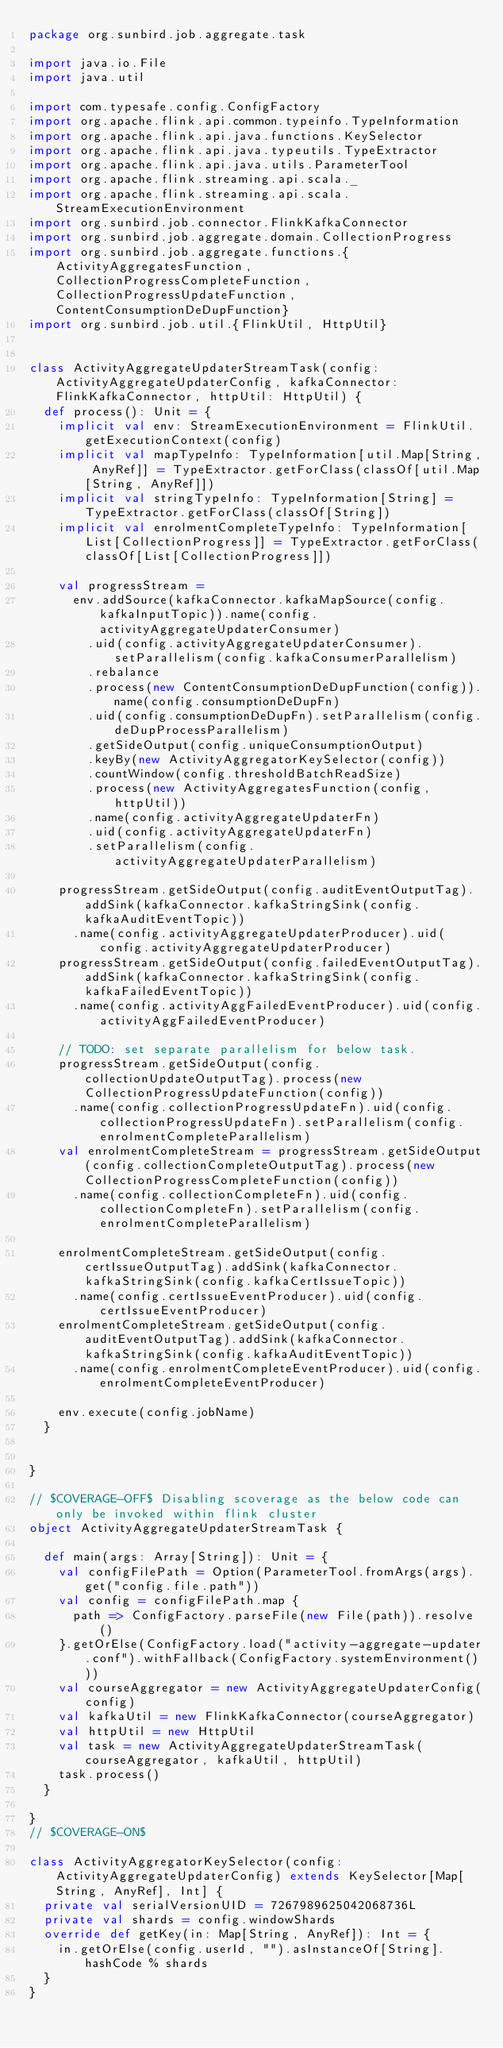Convert code to text. <code><loc_0><loc_0><loc_500><loc_500><_Scala_>package org.sunbird.job.aggregate.task

import java.io.File
import java.util

import com.typesafe.config.ConfigFactory
import org.apache.flink.api.common.typeinfo.TypeInformation
import org.apache.flink.api.java.functions.KeySelector
import org.apache.flink.api.java.typeutils.TypeExtractor
import org.apache.flink.api.java.utils.ParameterTool
import org.apache.flink.streaming.api.scala._
import org.apache.flink.streaming.api.scala.StreamExecutionEnvironment
import org.sunbird.job.connector.FlinkKafkaConnector
import org.sunbird.job.aggregate.domain.CollectionProgress
import org.sunbird.job.aggregate.functions.{ActivityAggregatesFunction, CollectionProgressCompleteFunction, CollectionProgressUpdateFunction, ContentConsumptionDeDupFunction}
import org.sunbird.job.util.{FlinkUtil, HttpUtil}


class ActivityAggregateUpdaterStreamTask(config: ActivityAggregateUpdaterConfig, kafkaConnector: FlinkKafkaConnector, httpUtil: HttpUtil) {
  def process(): Unit = {
    implicit val env: StreamExecutionEnvironment = FlinkUtil.getExecutionContext(config)
    implicit val mapTypeInfo: TypeInformation[util.Map[String, AnyRef]] = TypeExtractor.getForClass(classOf[util.Map[String, AnyRef]])
    implicit val stringTypeInfo: TypeInformation[String] = TypeExtractor.getForClass(classOf[String])
    implicit val enrolmentCompleteTypeInfo: TypeInformation[List[CollectionProgress]] = TypeExtractor.getForClass(classOf[List[CollectionProgress]])

    val progressStream =
      env.addSource(kafkaConnector.kafkaMapSource(config.kafkaInputTopic)).name(config.activityAggregateUpdaterConsumer)
        .uid(config.activityAggregateUpdaterConsumer).setParallelism(config.kafkaConsumerParallelism)
        .rebalance
        .process(new ContentConsumptionDeDupFunction(config)).name(config.consumptionDeDupFn)
        .uid(config.consumptionDeDupFn).setParallelism(config.deDupProcessParallelism)
        .getSideOutput(config.uniqueConsumptionOutput)
        .keyBy(new ActivityAggregatorKeySelector(config))
        .countWindow(config.thresholdBatchReadSize)
        .process(new ActivityAggregatesFunction(config, httpUtil))
        .name(config.activityAggregateUpdaterFn)
        .uid(config.activityAggregateUpdaterFn)
        .setParallelism(config.activityAggregateUpdaterParallelism)

    progressStream.getSideOutput(config.auditEventOutputTag).addSink(kafkaConnector.kafkaStringSink(config.kafkaAuditEventTopic))
      .name(config.activityAggregateUpdaterProducer).uid(config.activityAggregateUpdaterProducer)
    progressStream.getSideOutput(config.failedEventOutputTag).addSink(kafkaConnector.kafkaStringSink(config.kafkaFailedEventTopic))
      .name(config.activityAggFailedEventProducer).uid(config.activityAggFailedEventProducer)

    // TODO: set separate parallelism for below task.
    progressStream.getSideOutput(config.collectionUpdateOutputTag).process(new CollectionProgressUpdateFunction(config))
      .name(config.collectionProgressUpdateFn).uid(config.collectionProgressUpdateFn).setParallelism(config.enrolmentCompleteParallelism)
    val enrolmentCompleteStream = progressStream.getSideOutput(config.collectionCompleteOutputTag).process(new CollectionProgressCompleteFunction(config))
      .name(config.collectionCompleteFn).uid(config.collectionCompleteFn).setParallelism(config.enrolmentCompleteParallelism)

    enrolmentCompleteStream.getSideOutput(config.certIssueOutputTag).addSink(kafkaConnector.kafkaStringSink(config.kafkaCertIssueTopic))
      .name(config.certIssueEventProducer).uid(config.certIssueEventProducer)
    enrolmentCompleteStream.getSideOutput(config.auditEventOutputTag).addSink(kafkaConnector.kafkaStringSink(config.kafkaAuditEventTopic))
      .name(config.enrolmentCompleteEventProducer).uid(config.enrolmentCompleteEventProducer)

    env.execute(config.jobName)
  }


}

// $COVERAGE-OFF$ Disabling scoverage as the below code can only be invoked within flink cluster
object ActivityAggregateUpdaterStreamTask {

  def main(args: Array[String]): Unit = {
    val configFilePath = Option(ParameterTool.fromArgs(args).get("config.file.path"))
    val config = configFilePath.map {
      path => ConfigFactory.parseFile(new File(path)).resolve()
    }.getOrElse(ConfigFactory.load("activity-aggregate-updater.conf").withFallback(ConfigFactory.systemEnvironment()))
    val courseAggregator = new ActivityAggregateUpdaterConfig(config)
    val kafkaUtil = new FlinkKafkaConnector(courseAggregator)
    val httpUtil = new HttpUtil
    val task = new ActivityAggregateUpdaterStreamTask(courseAggregator, kafkaUtil, httpUtil)
    task.process()
  }

}
// $COVERAGE-ON$

class ActivityAggregatorKeySelector(config: ActivityAggregateUpdaterConfig) extends KeySelector[Map[String, AnyRef], Int] {
  private val serialVersionUID = 7267989625042068736L
  private val shards = config.windowShards
  override def getKey(in: Map[String, AnyRef]): Int = {
    in.getOrElse(config.userId, "").asInstanceOf[String].hashCode % shards
  }
}
</code> 